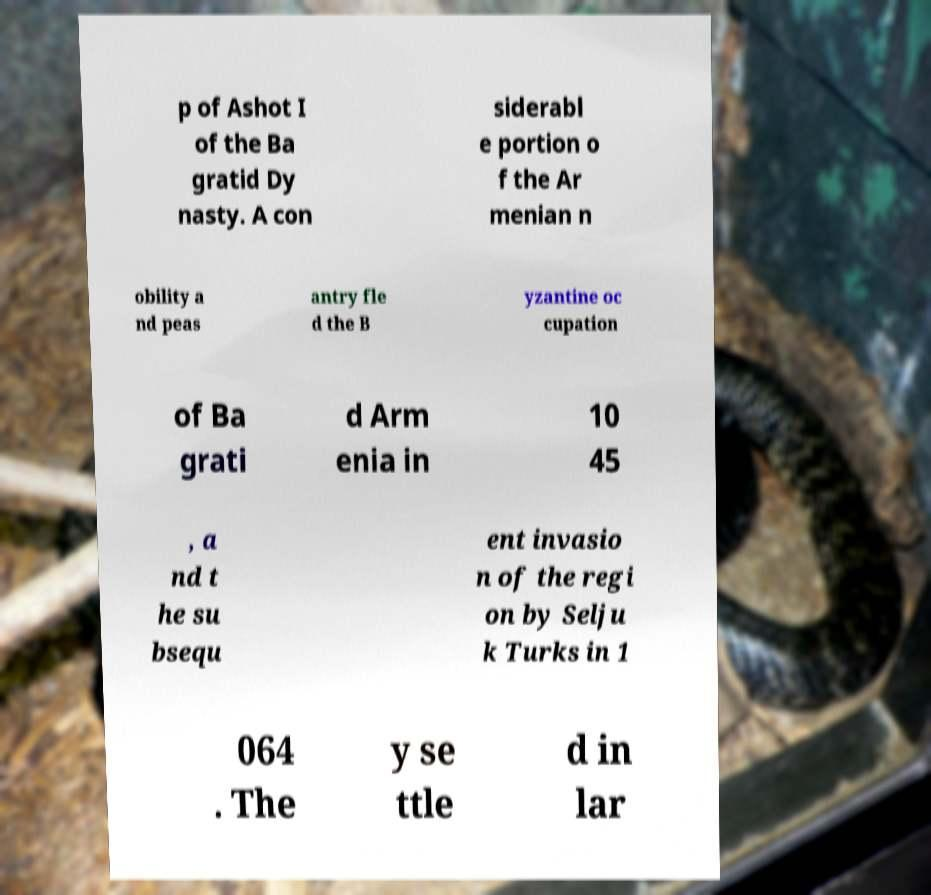I need the written content from this picture converted into text. Can you do that? p of Ashot I of the Ba gratid Dy nasty. A con siderabl e portion o f the Ar menian n obility a nd peas antry fle d the B yzantine oc cupation of Ba grati d Arm enia in 10 45 , a nd t he su bsequ ent invasio n of the regi on by Selju k Turks in 1 064 . The y se ttle d in lar 